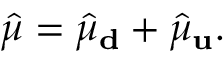<formula> <loc_0><loc_0><loc_500><loc_500>\hat { \mu } = \hat { \mu } _ { d } + \hat { \mu } _ { u } .</formula> 